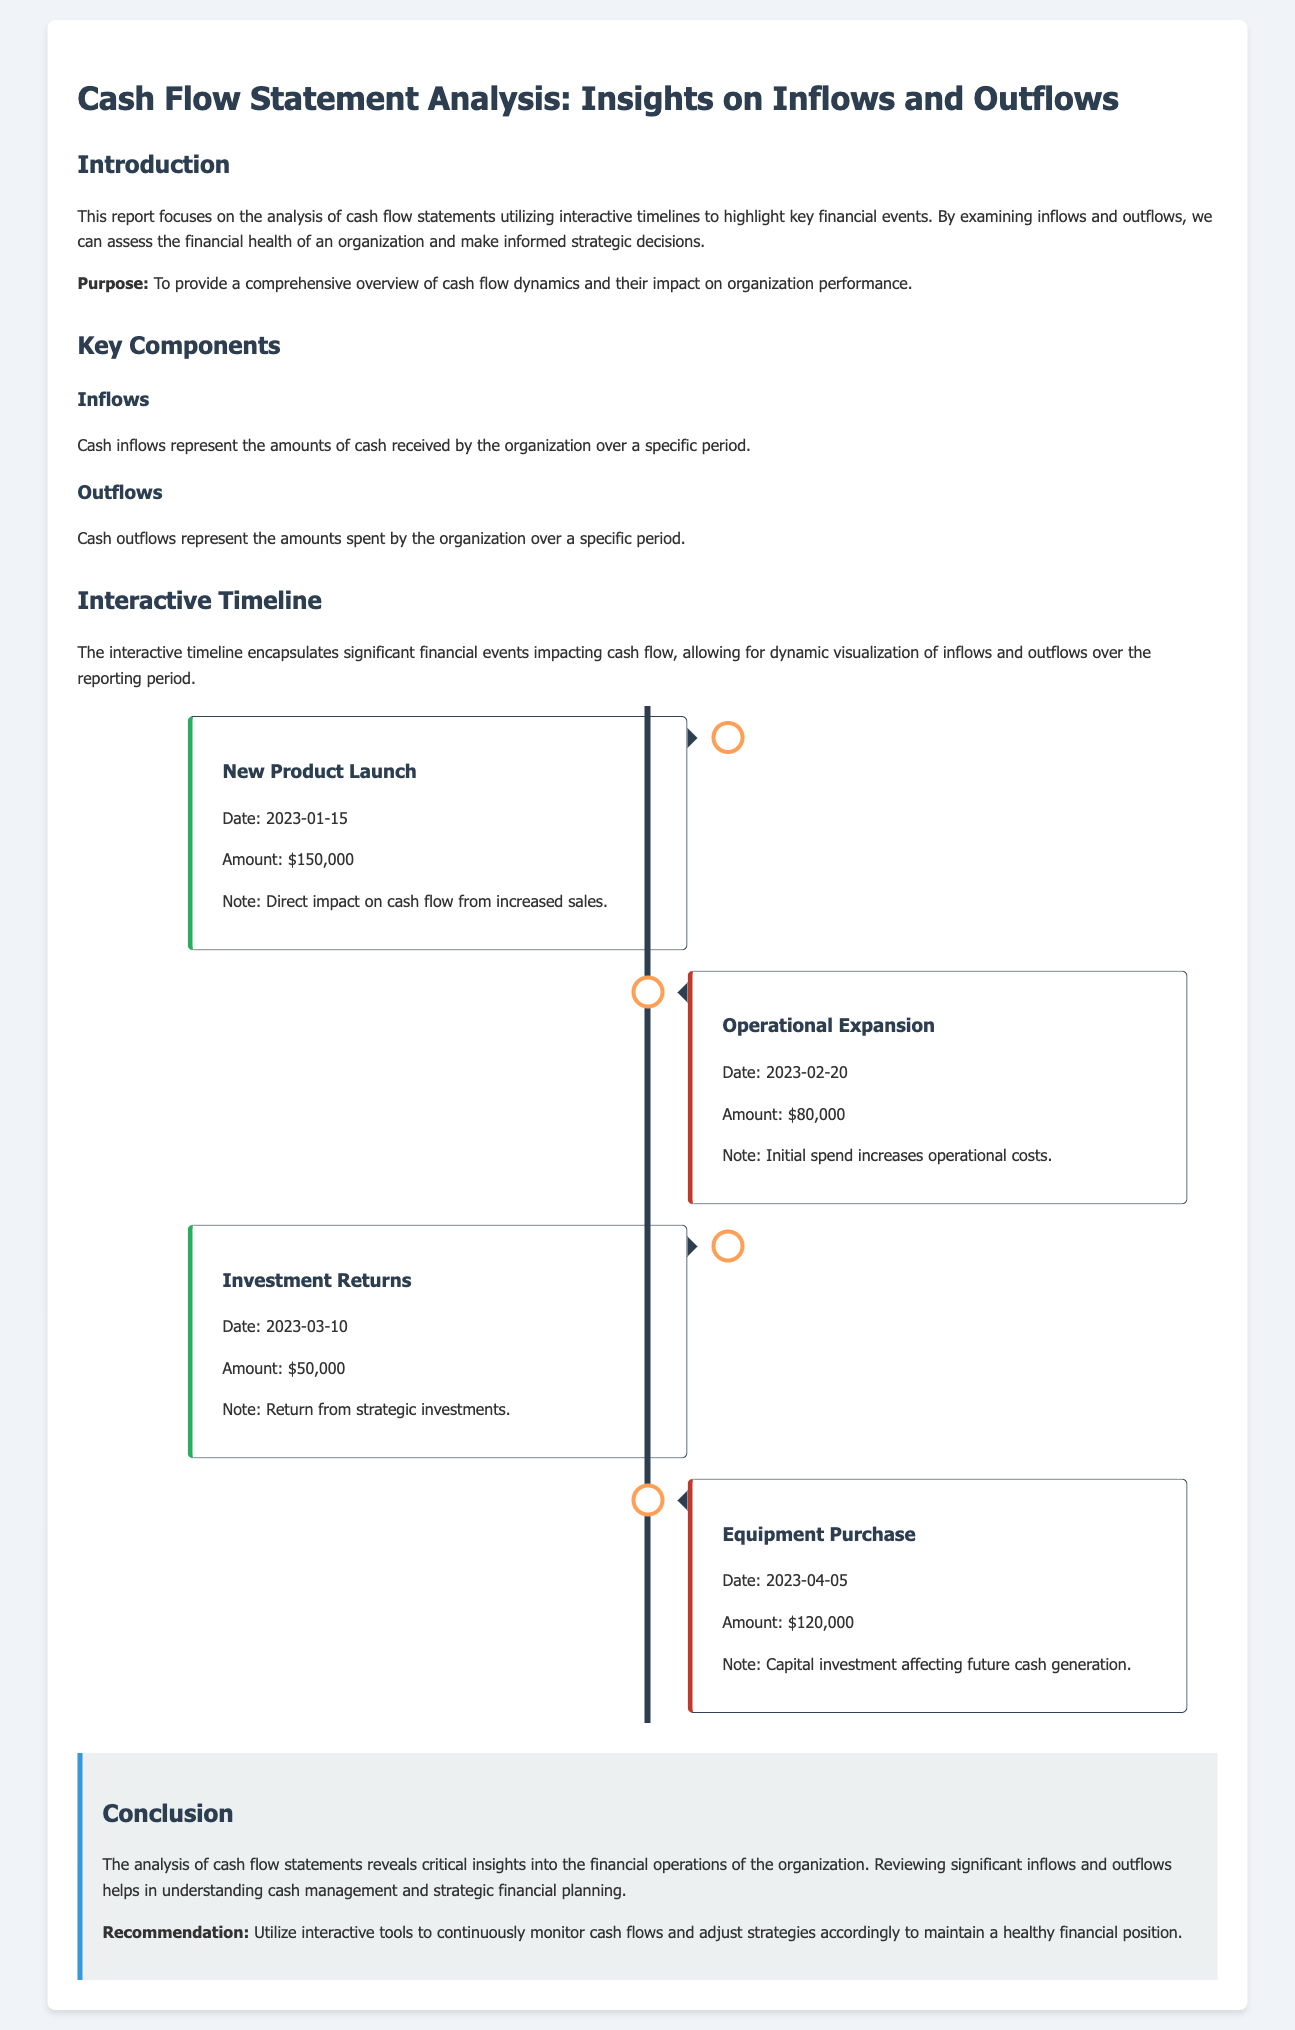What is the total amount of cash inflows presented? The total inflows can be calculated from the presented amounts: $150,000 (Product Launch) + $50,000 (Investment Returns) = $200,000.
Answer: $200,000 What was the date of the Operational Expansion outflow? The document states that the outflow for Operational Expansion occurred on February 20, 2023.
Answer: February 20, 2023 What was the amount spent on Equipment Purchase? The Equipment Purchase outflow amount is noted as $120,000.
Answer: $120,000 What type of event is associated with an inflow of $150,000? The inflow amount of $150,000 is associated with the New Product Launch event.
Answer: New Product Launch How many significant financial events are documented in the timeline? The document lists a total of four significant financial events: two inflows and two outflows.
Answer: Four events What note is provided regarding the Equipment Purchase? The note states that the Equipment Purchase is a capital investment affecting future cash generation.
Answer: Capital investment affecting future cash generation What is the primary purpose of the report? The primary purpose is to provide a comprehensive overview of cash flow dynamics and their impact on organization performance.
Answer: Comprehensive overview of cash flow dynamics What color represents cash inflows in the timeline? The cash inflows in the timeline are represented by the color green, specifically noted by the border color.
Answer: Green 